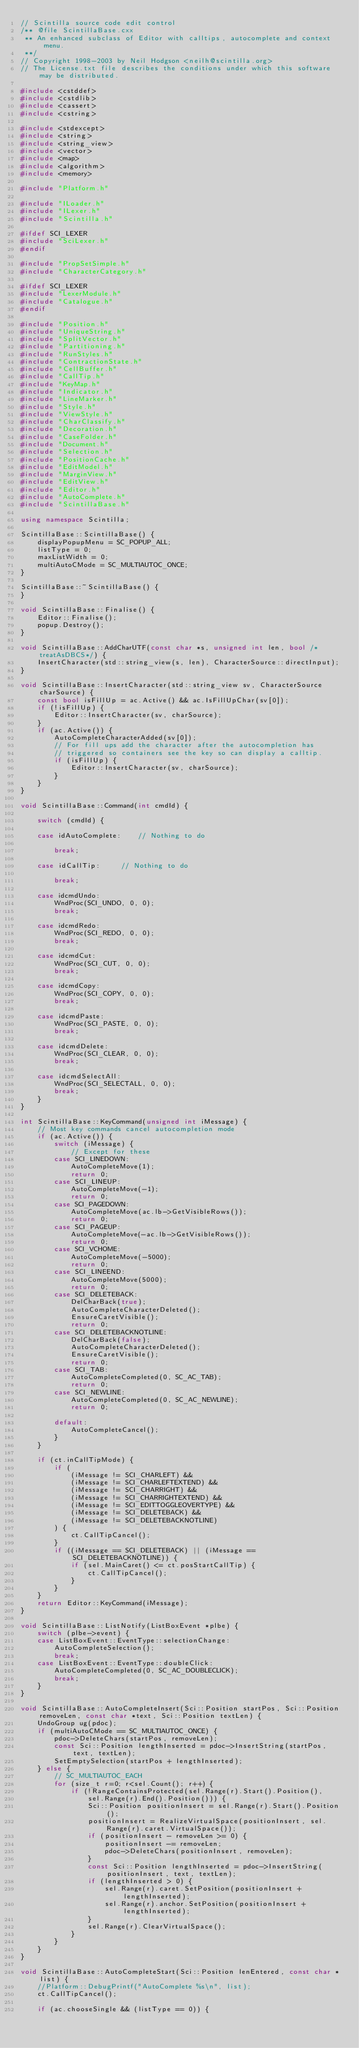Convert code to text. <code><loc_0><loc_0><loc_500><loc_500><_C++_>// Scintilla source code edit control
/** @file ScintillaBase.cxx
 ** An enhanced subclass of Editor with calltips, autocomplete and context menu.
 **/
// Copyright 1998-2003 by Neil Hodgson <neilh@scintilla.org>
// The License.txt file describes the conditions under which this software may be distributed.

#include <cstddef>
#include <cstdlib>
#include <cassert>
#include <cstring>

#include <stdexcept>
#include <string>
#include <string_view>
#include <vector>
#include <map>
#include <algorithm>
#include <memory>

#include "Platform.h"

#include "ILoader.h"
#include "ILexer.h"
#include "Scintilla.h"

#ifdef SCI_LEXER
#include "SciLexer.h"
#endif

#include "PropSetSimple.h"
#include "CharacterCategory.h"

#ifdef SCI_LEXER
#include "LexerModule.h"
#include "Catalogue.h"
#endif

#include "Position.h"
#include "UniqueString.h"
#include "SplitVector.h"
#include "Partitioning.h"
#include "RunStyles.h"
#include "ContractionState.h"
#include "CellBuffer.h"
#include "CallTip.h"
#include "KeyMap.h"
#include "Indicator.h"
#include "LineMarker.h"
#include "Style.h"
#include "ViewStyle.h"
#include "CharClassify.h"
#include "Decoration.h"
#include "CaseFolder.h"
#include "Document.h"
#include "Selection.h"
#include "PositionCache.h"
#include "EditModel.h"
#include "MarginView.h"
#include "EditView.h"
#include "Editor.h"
#include "AutoComplete.h"
#include "ScintillaBase.h"

using namespace Scintilla;

ScintillaBase::ScintillaBase() {
	displayPopupMenu = SC_POPUP_ALL;
	listType = 0;
	maxListWidth = 0;
	multiAutoCMode = SC_MULTIAUTOC_ONCE;
}

ScintillaBase::~ScintillaBase() {
}

void ScintillaBase::Finalise() {
	Editor::Finalise();
	popup.Destroy();
}

void ScintillaBase::AddCharUTF(const char *s, unsigned int len, bool /*treatAsDBCS*/) {
	InsertCharacter(std::string_view(s, len), CharacterSource::directInput);
}

void ScintillaBase::InsertCharacter(std::string_view sv, CharacterSource charSource) {
	const bool isFillUp = ac.Active() && ac.IsFillUpChar(sv[0]);
	if (!isFillUp) {
		Editor::InsertCharacter(sv, charSource);
	}
	if (ac.Active()) {
		AutoCompleteCharacterAdded(sv[0]);
		// For fill ups add the character after the autocompletion has
		// triggered so containers see the key so can display a calltip.
		if (isFillUp) {
			Editor::InsertCharacter(sv, charSource);
		}
	}
}

void ScintillaBase::Command(int cmdId) {

	switch (cmdId) {

	case idAutoComplete:  	// Nothing to do

		break;

	case idCallTip:  	// Nothing to do

		break;

	case idcmdUndo:
		WndProc(SCI_UNDO, 0, 0);
		break;

	case idcmdRedo:
		WndProc(SCI_REDO, 0, 0);
		break;

	case idcmdCut:
		WndProc(SCI_CUT, 0, 0);
		break;

	case idcmdCopy:
		WndProc(SCI_COPY, 0, 0);
		break;

	case idcmdPaste:
		WndProc(SCI_PASTE, 0, 0);
		break;

	case idcmdDelete:
		WndProc(SCI_CLEAR, 0, 0);
		break;

	case idcmdSelectAll:
		WndProc(SCI_SELECTALL, 0, 0);
		break;
	}
}

int ScintillaBase::KeyCommand(unsigned int iMessage) {
	// Most key commands cancel autocompletion mode
	if (ac.Active()) {
		switch (iMessage) {
			// Except for these
		case SCI_LINEDOWN:
			AutoCompleteMove(1);
			return 0;
		case SCI_LINEUP:
			AutoCompleteMove(-1);
			return 0;
		case SCI_PAGEDOWN:
			AutoCompleteMove(ac.lb->GetVisibleRows());
			return 0;
		case SCI_PAGEUP:
			AutoCompleteMove(-ac.lb->GetVisibleRows());
			return 0;
		case SCI_VCHOME:
			AutoCompleteMove(-5000);
			return 0;
		case SCI_LINEEND:
			AutoCompleteMove(5000);
			return 0;
		case SCI_DELETEBACK:
			DelCharBack(true);
			AutoCompleteCharacterDeleted();
			EnsureCaretVisible();
			return 0;
		case SCI_DELETEBACKNOTLINE:
			DelCharBack(false);
			AutoCompleteCharacterDeleted();
			EnsureCaretVisible();
			return 0;
		case SCI_TAB:
			AutoCompleteCompleted(0, SC_AC_TAB);
			return 0;
		case SCI_NEWLINE:
			AutoCompleteCompleted(0, SC_AC_NEWLINE);
			return 0;

		default:
			AutoCompleteCancel();
		}
	}

	if (ct.inCallTipMode) {
		if (
		    (iMessage != SCI_CHARLEFT) &&
		    (iMessage != SCI_CHARLEFTEXTEND) &&
		    (iMessage != SCI_CHARRIGHT) &&
		    (iMessage != SCI_CHARRIGHTEXTEND) &&
		    (iMessage != SCI_EDITTOGGLEOVERTYPE) &&
		    (iMessage != SCI_DELETEBACK) &&
		    (iMessage != SCI_DELETEBACKNOTLINE)
		) {
			ct.CallTipCancel();
		}
		if ((iMessage == SCI_DELETEBACK) || (iMessage == SCI_DELETEBACKNOTLINE)) {
			if (sel.MainCaret() <= ct.posStartCallTip) {
				ct.CallTipCancel();
			}
		}
	}
	return Editor::KeyCommand(iMessage);
}

void ScintillaBase::ListNotify(ListBoxEvent *plbe) {
	switch (plbe->event) {
	case ListBoxEvent::EventType::selectionChange:
		AutoCompleteSelection();
		break;
	case ListBoxEvent::EventType::doubleClick:
		AutoCompleteCompleted(0, SC_AC_DOUBLECLICK);
		break;
	}
}

void ScintillaBase::AutoCompleteInsert(Sci::Position startPos, Sci::Position removeLen, const char *text, Sci::Position textLen) {
	UndoGroup ug(pdoc);
	if (multiAutoCMode == SC_MULTIAUTOC_ONCE) {
		pdoc->DeleteChars(startPos, removeLen);
		const Sci::Position lengthInserted = pdoc->InsertString(startPos, text, textLen);
		SetEmptySelection(startPos + lengthInserted);
	} else {
		// SC_MULTIAUTOC_EACH
		for (size_t r=0; r<sel.Count(); r++) {
			if (!RangeContainsProtected(sel.Range(r).Start().Position(),
				sel.Range(r).End().Position())) {
				Sci::Position positionInsert = sel.Range(r).Start().Position();
				positionInsert = RealizeVirtualSpace(positionInsert, sel.Range(r).caret.VirtualSpace());
				if (positionInsert - removeLen >= 0) {
					positionInsert -= removeLen;
					pdoc->DeleteChars(positionInsert, removeLen);
				}
				const Sci::Position lengthInserted = pdoc->InsertString(positionInsert, text, textLen);
				if (lengthInserted > 0) {
					sel.Range(r).caret.SetPosition(positionInsert + lengthInserted);
					sel.Range(r).anchor.SetPosition(positionInsert + lengthInserted);
				}
				sel.Range(r).ClearVirtualSpace();
			}
		}
	}
}

void ScintillaBase::AutoCompleteStart(Sci::Position lenEntered, const char *list) {
	//Platform::DebugPrintf("AutoComplete %s\n", list);
	ct.CallTipCancel();

	if (ac.chooseSingle && (listType == 0)) {</code> 